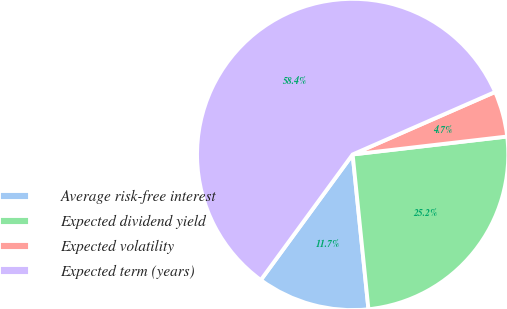<chart> <loc_0><loc_0><loc_500><loc_500><pie_chart><fcel>Average risk-free interest<fcel>Expected dividend yield<fcel>Expected volatility<fcel>Expected term (years)<nl><fcel>11.67%<fcel>25.22%<fcel>4.74%<fcel>58.37%<nl></chart> 